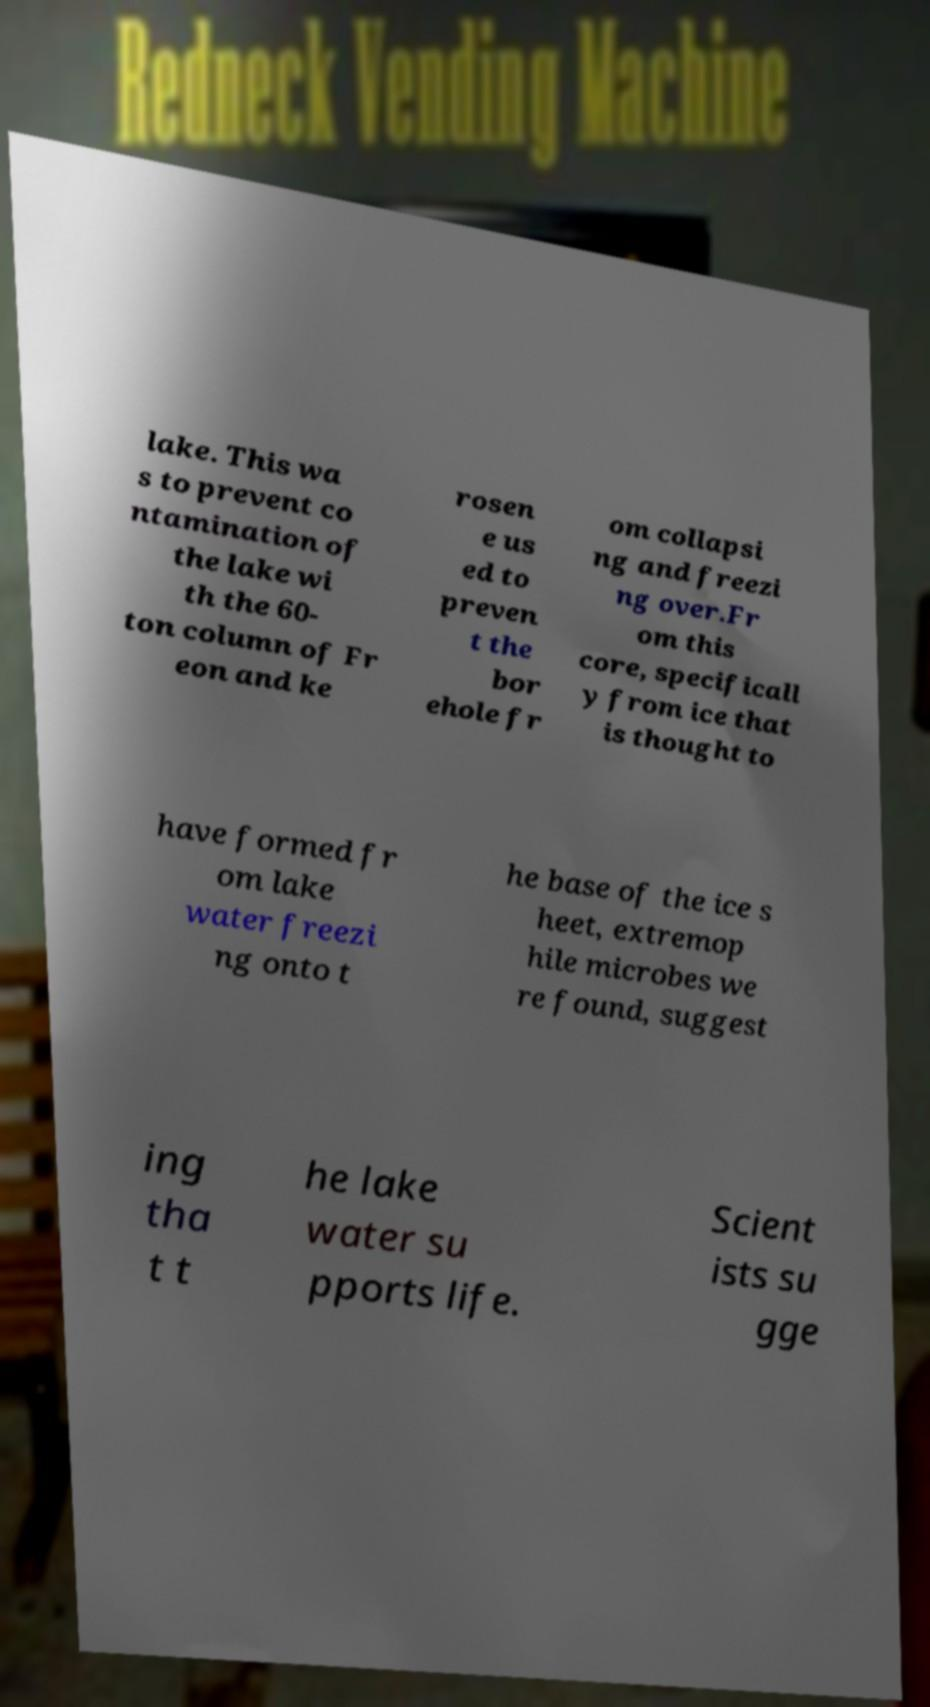For documentation purposes, I need the text within this image transcribed. Could you provide that? lake. This wa s to prevent co ntamination of the lake wi th the 60- ton column of Fr eon and ke rosen e us ed to preven t the bor ehole fr om collapsi ng and freezi ng over.Fr om this core, specificall y from ice that is thought to have formed fr om lake water freezi ng onto t he base of the ice s heet, extremop hile microbes we re found, suggest ing tha t t he lake water su pports life. Scient ists su gge 